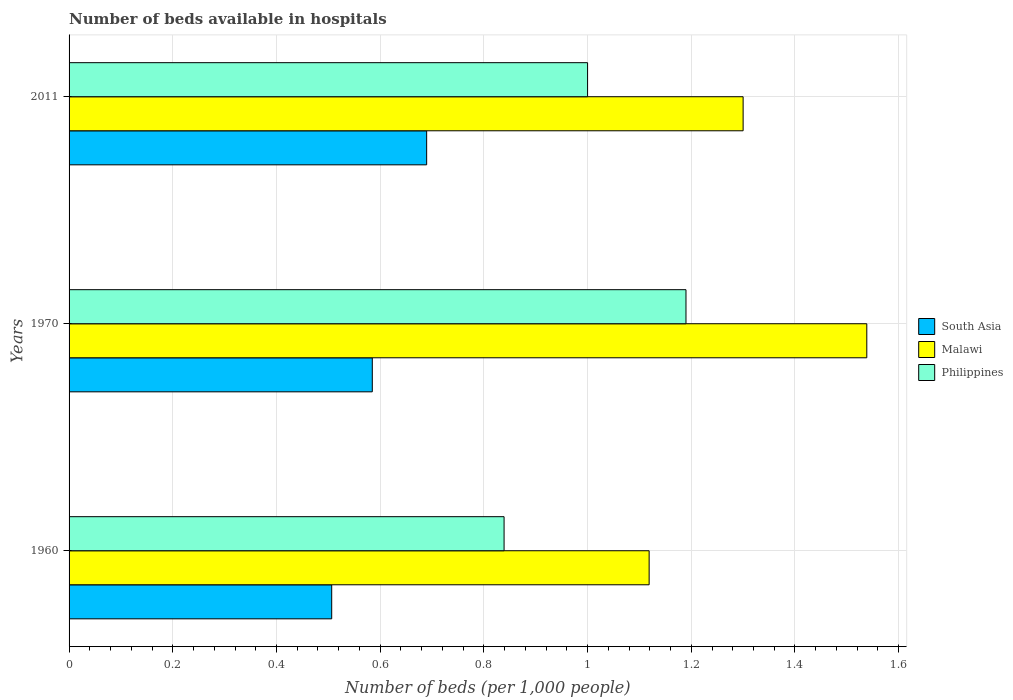How many groups of bars are there?
Give a very brief answer. 3. Are the number of bars per tick equal to the number of legend labels?
Provide a succinct answer. Yes. Are the number of bars on each tick of the Y-axis equal?
Ensure brevity in your answer.  Yes. How many bars are there on the 2nd tick from the top?
Your response must be concise. 3. In how many cases, is the number of bars for a given year not equal to the number of legend labels?
Your answer should be very brief. 0. What is the number of beds in the hospiatls of in Philippines in 1960?
Make the answer very short. 0.84. Across all years, what is the maximum number of beds in the hospiatls of in Malawi?
Your response must be concise. 1.54. Across all years, what is the minimum number of beds in the hospiatls of in South Asia?
Provide a short and direct response. 0.51. In which year was the number of beds in the hospiatls of in Malawi minimum?
Your response must be concise. 1960. What is the total number of beds in the hospiatls of in South Asia in the graph?
Offer a very short reply. 1.78. What is the difference between the number of beds in the hospiatls of in Malawi in 1960 and that in 2011?
Make the answer very short. -0.18. What is the difference between the number of beds in the hospiatls of in South Asia in 2011 and the number of beds in the hospiatls of in Philippines in 1960?
Offer a terse response. -0.15. What is the average number of beds in the hospiatls of in Philippines per year?
Your response must be concise. 1.01. In the year 2011, what is the difference between the number of beds in the hospiatls of in Malawi and number of beds in the hospiatls of in Philippines?
Offer a very short reply. 0.3. In how many years, is the number of beds in the hospiatls of in Philippines greater than 0.2 ?
Keep it short and to the point. 3. What is the ratio of the number of beds in the hospiatls of in Philippines in 1970 to that in 2011?
Keep it short and to the point. 1.19. Is the difference between the number of beds in the hospiatls of in Malawi in 1960 and 1970 greater than the difference between the number of beds in the hospiatls of in Philippines in 1960 and 1970?
Make the answer very short. No. What is the difference between the highest and the second highest number of beds in the hospiatls of in South Asia?
Offer a very short reply. 0.1. What is the difference between the highest and the lowest number of beds in the hospiatls of in Philippines?
Your response must be concise. 0.35. Is the sum of the number of beds in the hospiatls of in Philippines in 1970 and 2011 greater than the maximum number of beds in the hospiatls of in Malawi across all years?
Your answer should be compact. Yes. Is it the case that in every year, the sum of the number of beds in the hospiatls of in Malawi and number of beds in the hospiatls of in South Asia is greater than the number of beds in the hospiatls of in Philippines?
Ensure brevity in your answer.  Yes. What is the difference between two consecutive major ticks on the X-axis?
Provide a succinct answer. 0.2. Are the values on the major ticks of X-axis written in scientific E-notation?
Give a very brief answer. No. Does the graph contain any zero values?
Give a very brief answer. No. Does the graph contain grids?
Provide a short and direct response. Yes. How are the legend labels stacked?
Keep it short and to the point. Vertical. What is the title of the graph?
Make the answer very short. Number of beds available in hospitals. Does "French Polynesia" appear as one of the legend labels in the graph?
Your answer should be compact. No. What is the label or title of the X-axis?
Provide a succinct answer. Number of beds (per 1,0 people). What is the Number of beds (per 1,000 people) in South Asia in 1960?
Your answer should be very brief. 0.51. What is the Number of beds (per 1,000 people) in Malawi in 1960?
Offer a terse response. 1.12. What is the Number of beds (per 1,000 people) in Philippines in 1960?
Your answer should be compact. 0.84. What is the Number of beds (per 1,000 people) of South Asia in 1970?
Offer a very short reply. 0.58. What is the Number of beds (per 1,000 people) of Malawi in 1970?
Make the answer very short. 1.54. What is the Number of beds (per 1,000 people) in Philippines in 1970?
Your response must be concise. 1.19. What is the Number of beds (per 1,000 people) in South Asia in 2011?
Offer a terse response. 0.69. What is the Number of beds (per 1,000 people) in Malawi in 2011?
Your answer should be very brief. 1.3. Across all years, what is the maximum Number of beds (per 1,000 people) of South Asia?
Provide a succinct answer. 0.69. Across all years, what is the maximum Number of beds (per 1,000 people) in Malawi?
Ensure brevity in your answer.  1.54. Across all years, what is the maximum Number of beds (per 1,000 people) of Philippines?
Provide a succinct answer. 1.19. Across all years, what is the minimum Number of beds (per 1,000 people) in South Asia?
Your response must be concise. 0.51. Across all years, what is the minimum Number of beds (per 1,000 people) in Malawi?
Ensure brevity in your answer.  1.12. Across all years, what is the minimum Number of beds (per 1,000 people) in Philippines?
Your answer should be very brief. 0.84. What is the total Number of beds (per 1,000 people) in South Asia in the graph?
Provide a succinct answer. 1.78. What is the total Number of beds (per 1,000 people) in Malawi in the graph?
Your answer should be very brief. 3.96. What is the total Number of beds (per 1,000 people) in Philippines in the graph?
Give a very brief answer. 3.03. What is the difference between the Number of beds (per 1,000 people) in South Asia in 1960 and that in 1970?
Your answer should be very brief. -0.08. What is the difference between the Number of beds (per 1,000 people) of Malawi in 1960 and that in 1970?
Give a very brief answer. -0.42. What is the difference between the Number of beds (per 1,000 people) in Philippines in 1960 and that in 1970?
Offer a terse response. -0.35. What is the difference between the Number of beds (per 1,000 people) of South Asia in 1960 and that in 2011?
Your answer should be compact. -0.18. What is the difference between the Number of beds (per 1,000 people) of Malawi in 1960 and that in 2011?
Ensure brevity in your answer.  -0.18. What is the difference between the Number of beds (per 1,000 people) of Philippines in 1960 and that in 2011?
Give a very brief answer. -0.16. What is the difference between the Number of beds (per 1,000 people) in South Asia in 1970 and that in 2011?
Offer a very short reply. -0.1. What is the difference between the Number of beds (per 1,000 people) in Malawi in 1970 and that in 2011?
Make the answer very short. 0.24. What is the difference between the Number of beds (per 1,000 people) in Philippines in 1970 and that in 2011?
Offer a very short reply. 0.19. What is the difference between the Number of beds (per 1,000 people) in South Asia in 1960 and the Number of beds (per 1,000 people) in Malawi in 1970?
Keep it short and to the point. -1.03. What is the difference between the Number of beds (per 1,000 people) in South Asia in 1960 and the Number of beds (per 1,000 people) in Philippines in 1970?
Make the answer very short. -0.68. What is the difference between the Number of beds (per 1,000 people) of Malawi in 1960 and the Number of beds (per 1,000 people) of Philippines in 1970?
Provide a succinct answer. -0.07. What is the difference between the Number of beds (per 1,000 people) in South Asia in 1960 and the Number of beds (per 1,000 people) in Malawi in 2011?
Provide a short and direct response. -0.79. What is the difference between the Number of beds (per 1,000 people) in South Asia in 1960 and the Number of beds (per 1,000 people) in Philippines in 2011?
Make the answer very short. -0.49. What is the difference between the Number of beds (per 1,000 people) of Malawi in 1960 and the Number of beds (per 1,000 people) of Philippines in 2011?
Offer a terse response. 0.12. What is the difference between the Number of beds (per 1,000 people) of South Asia in 1970 and the Number of beds (per 1,000 people) of Malawi in 2011?
Offer a very short reply. -0.72. What is the difference between the Number of beds (per 1,000 people) in South Asia in 1970 and the Number of beds (per 1,000 people) in Philippines in 2011?
Provide a succinct answer. -0.42. What is the difference between the Number of beds (per 1,000 people) in Malawi in 1970 and the Number of beds (per 1,000 people) in Philippines in 2011?
Your answer should be very brief. 0.54. What is the average Number of beds (per 1,000 people) in South Asia per year?
Offer a terse response. 0.59. What is the average Number of beds (per 1,000 people) of Malawi per year?
Offer a terse response. 1.32. What is the average Number of beds (per 1,000 people) of Philippines per year?
Ensure brevity in your answer.  1.01. In the year 1960, what is the difference between the Number of beds (per 1,000 people) of South Asia and Number of beds (per 1,000 people) of Malawi?
Ensure brevity in your answer.  -0.61. In the year 1960, what is the difference between the Number of beds (per 1,000 people) in South Asia and Number of beds (per 1,000 people) in Philippines?
Your answer should be very brief. -0.33. In the year 1960, what is the difference between the Number of beds (per 1,000 people) in Malawi and Number of beds (per 1,000 people) in Philippines?
Provide a short and direct response. 0.28. In the year 1970, what is the difference between the Number of beds (per 1,000 people) of South Asia and Number of beds (per 1,000 people) of Malawi?
Ensure brevity in your answer.  -0.95. In the year 1970, what is the difference between the Number of beds (per 1,000 people) in South Asia and Number of beds (per 1,000 people) in Philippines?
Offer a very short reply. -0.6. In the year 1970, what is the difference between the Number of beds (per 1,000 people) in Malawi and Number of beds (per 1,000 people) in Philippines?
Ensure brevity in your answer.  0.35. In the year 2011, what is the difference between the Number of beds (per 1,000 people) in South Asia and Number of beds (per 1,000 people) in Malawi?
Provide a succinct answer. -0.61. In the year 2011, what is the difference between the Number of beds (per 1,000 people) in South Asia and Number of beds (per 1,000 people) in Philippines?
Your answer should be compact. -0.31. In the year 2011, what is the difference between the Number of beds (per 1,000 people) of Malawi and Number of beds (per 1,000 people) of Philippines?
Make the answer very short. 0.3. What is the ratio of the Number of beds (per 1,000 people) in South Asia in 1960 to that in 1970?
Offer a very short reply. 0.87. What is the ratio of the Number of beds (per 1,000 people) of Malawi in 1960 to that in 1970?
Offer a terse response. 0.73. What is the ratio of the Number of beds (per 1,000 people) of Philippines in 1960 to that in 1970?
Your answer should be very brief. 0.71. What is the ratio of the Number of beds (per 1,000 people) in South Asia in 1960 to that in 2011?
Offer a terse response. 0.73. What is the ratio of the Number of beds (per 1,000 people) in Malawi in 1960 to that in 2011?
Offer a terse response. 0.86. What is the ratio of the Number of beds (per 1,000 people) in Philippines in 1960 to that in 2011?
Offer a terse response. 0.84. What is the ratio of the Number of beds (per 1,000 people) of South Asia in 1970 to that in 2011?
Offer a very short reply. 0.85. What is the ratio of the Number of beds (per 1,000 people) of Malawi in 1970 to that in 2011?
Ensure brevity in your answer.  1.18. What is the ratio of the Number of beds (per 1,000 people) of Philippines in 1970 to that in 2011?
Your response must be concise. 1.19. What is the difference between the highest and the second highest Number of beds (per 1,000 people) in South Asia?
Keep it short and to the point. 0.1. What is the difference between the highest and the second highest Number of beds (per 1,000 people) of Malawi?
Your answer should be compact. 0.24. What is the difference between the highest and the second highest Number of beds (per 1,000 people) of Philippines?
Keep it short and to the point. 0.19. What is the difference between the highest and the lowest Number of beds (per 1,000 people) of South Asia?
Your response must be concise. 0.18. What is the difference between the highest and the lowest Number of beds (per 1,000 people) of Malawi?
Provide a short and direct response. 0.42. What is the difference between the highest and the lowest Number of beds (per 1,000 people) of Philippines?
Provide a succinct answer. 0.35. 